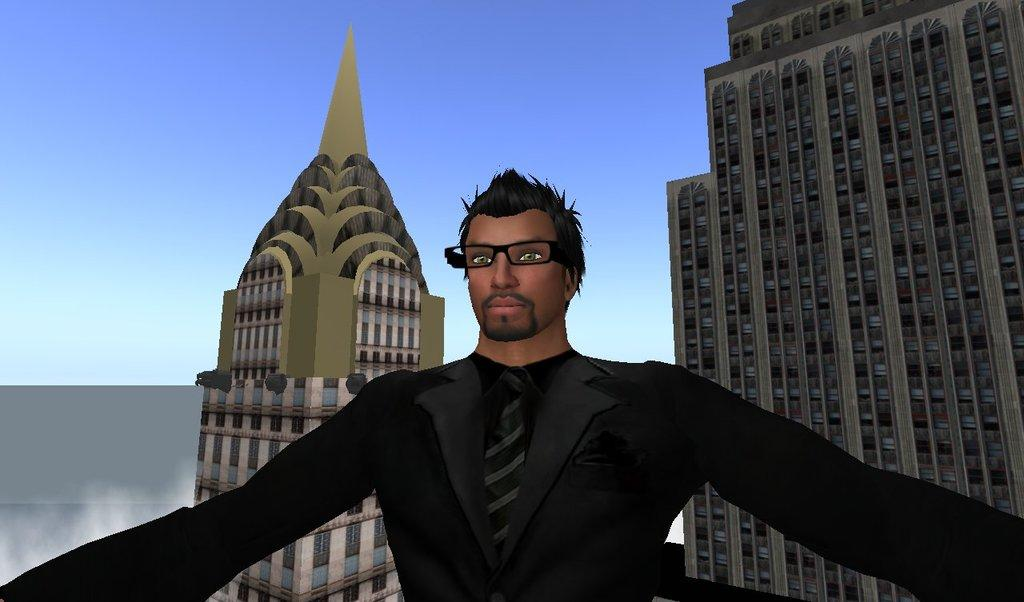What is one characteristic of the person in the animation? The person in the animation is wearing glasses. What can be seen in the background of the animation? There are buildings in the background of the animation. What part of the person's body is used to cover the buildings in the animation? There is no part of the person's body used to cover the buildings in the animation, as the buildings are in the background and not interacting with the person. 